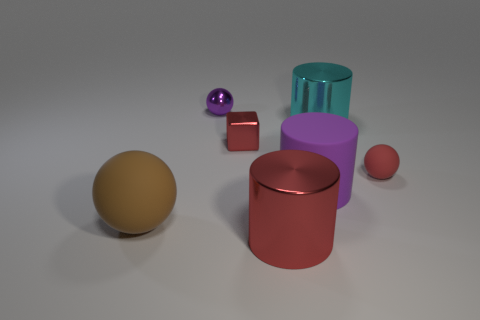Add 3 small brown metallic spheres. How many objects exist? 10 Subtract all shiny cylinders. How many cylinders are left? 1 Subtract all purple spheres. How many spheres are left? 2 Subtract 1 red cubes. How many objects are left? 6 Subtract all cubes. How many objects are left? 6 Subtract 1 spheres. How many spheres are left? 2 Subtract all blue cylinders. Subtract all purple balls. How many cylinders are left? 3 Subtract all brown balls. How many red cylinders are left? 1 Subtract all brown things. Subtract all red matte objects. How many objects are left? 5 Add 4 brown spheres. How many brown spheres are left? 5 